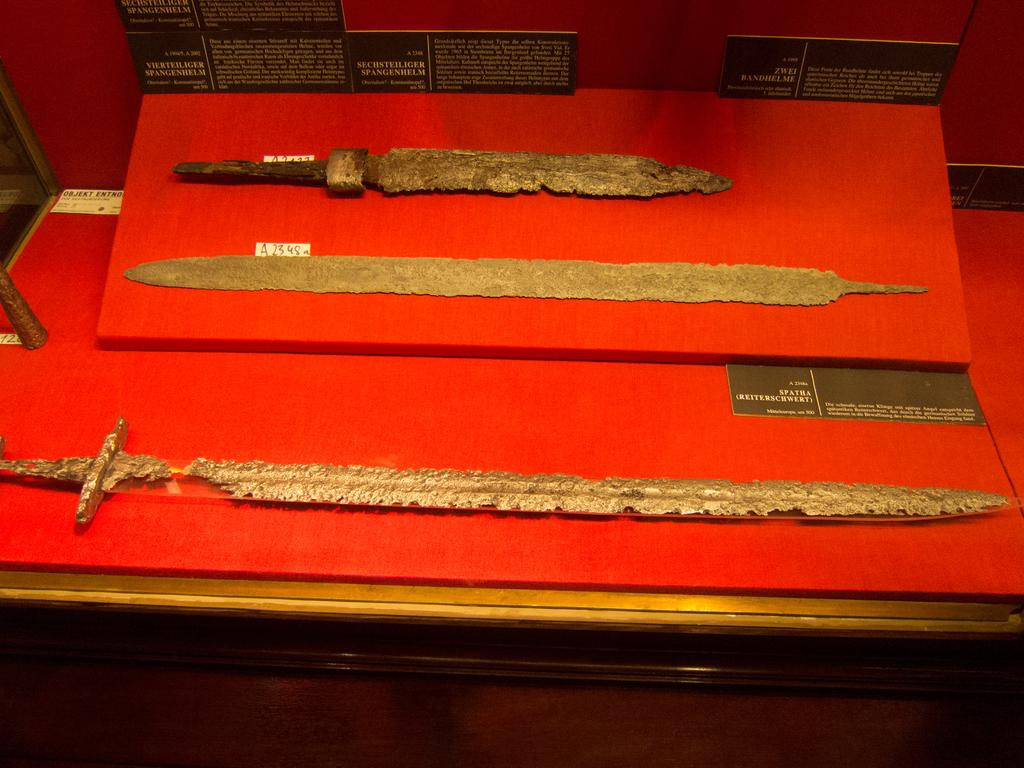What type of objects are in the image? There are three ancient objects in the image. What is the color of the surface on which the objects are placed? The ancient objects are placed on a red surface. Are there any additional items or information related to the objects in the image? Yes, there are black cards with information around the objects. How many cherries are on top of the ancient objects in the image? There are no cherries present in the image. Is there any evidence of a crime scene in the image? There is no indication of a crime scene in the image; it features ancient objects on a red surface with black cards containing information. 